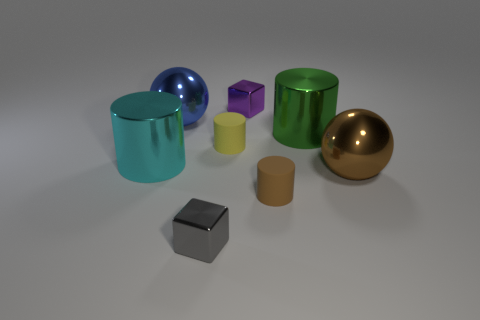What geometric shapes are visible in the image, and are there any repeating shapes? The image contains several geometric shapes including spheres, cylinders, and cubes. The cylinders and cubes repeat with various sizes and colors. These shapes collectively contribute to a structured yet varied assembly, letting each form stand out while harmoniously blending with the others. 